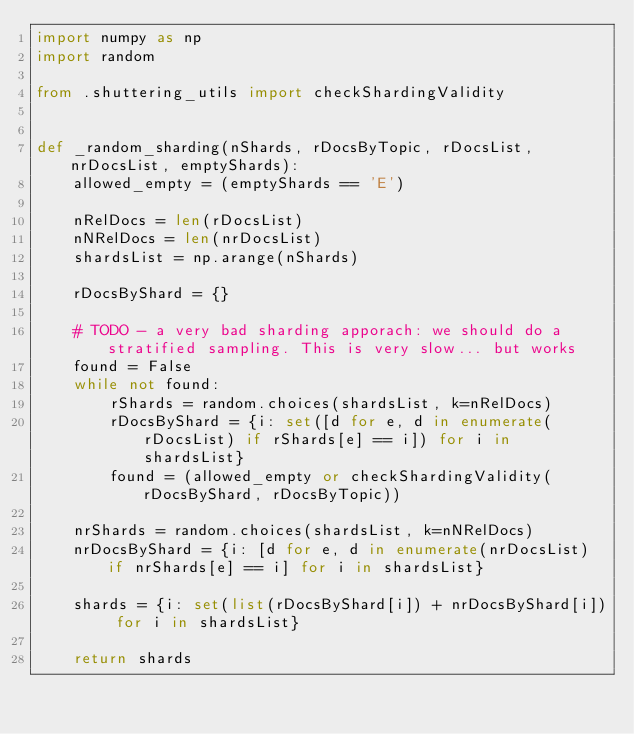Convert code to text. <code><loc_0><loc_0><loc_500><loc_500><_Python_>import numpy as np
import random

from .shuttering_utils import checkShardingValidity


def _random_sharding(nShards, rDocsByTopic, rDocsList, nrDocsList, emptyShards):
    allowed_empty = (emptyShards == 'E')

    nRelDocs = len(rDocsList)
    nNRelDocs = len(nrDocsList)
    shardsList = np.arange(nShards)

    rDocsByShard = {}

    # TODO - a very bad sharding apporach: we should do a stratified sampling. This is very slow... but works
    found = False
    while not found:
        rShards = random.choices(shardsList, k=nRelDocs)
        rDocsByShard = {i: set([d for e, d in enumerate(rDocsList) if rShards[e] == i]) for i in shardsList}
        found = (allowed_empty or checkShardingValidity(rDocsByShard, rDocsByTopic))

    nrShards = random.choices(shardsList, k=nNRelDocs)
    nrDocsByShard = {i: [d for e, d in enumerate(nrDocsList) if nrShards[e] == i] for i in shardsList}

    shards = {i: set(list(rDocsByShard[i]) + nrDocsByShard[i]) for i in shardsList}

    return shards
</code> 